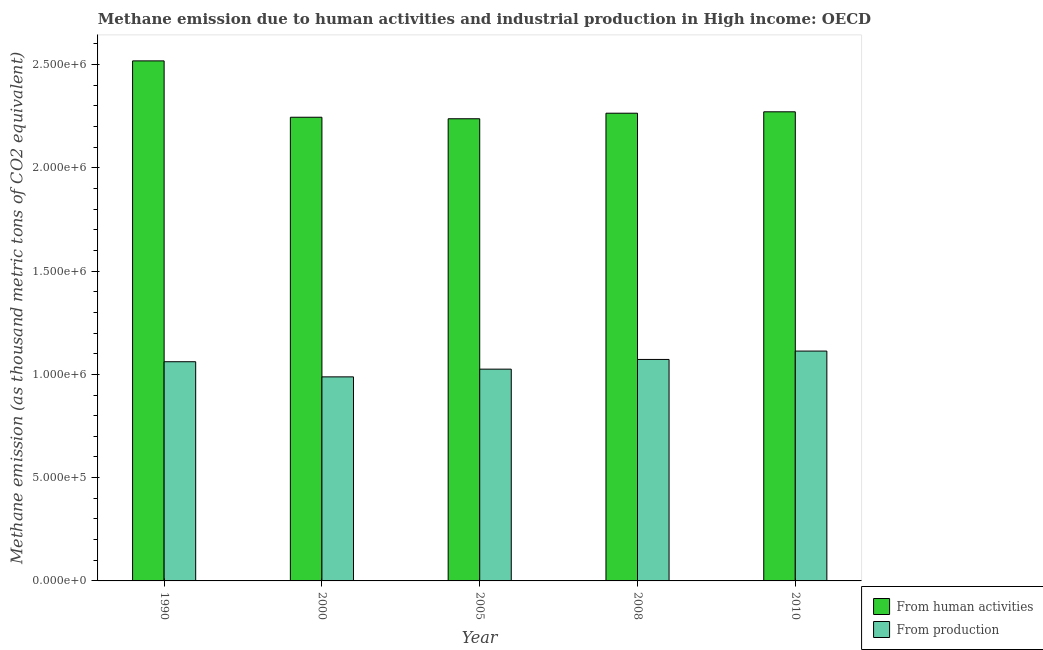How many different coloured bars are there?
Ensure brevity in your answer.  2. How many groups of bars are there?
Provide a short and direct response. 5. How many bars are there on the 3rd tick from the right?
Give a very brief answer. 2. In how many cases, is the number of bars for a given year not equal to the number of legend labels?
Keep it short and to the point. 0. What is the amount of emissions generated from industries in 1990?
Offer a terse response. 1.06e+06. Across all years, what is the maximum amount of emissions generated from industries?
Give a very brief answer. 1.11e+06. Across all years, what is the minimum amount of emissions generated from industries?
Provide a succinct answer. 9.88e+05. What is the total amount of emissions generated from industries in the graph?
Your response must be concise. 5.26e+06. What is the difference between the amount of emissions generated from industries in 1990 and that in 2000?
Provide a short and direct response. 7.33e+04. What is the difference between the amount of emissions generated from industries in 2005 and the amount of emissions from human activities in 2010?
Keep it short and to the point. -8.75e+04. What is the average amount of emissions from human activities per year?
Give a very brief answer. 2.31e+06. In the year 2000, what is the difference between the amount of emissions from human activities and amount of emissions generated from industries?
Provide a short and direct response. 0. In how many years, is the amount of emissions generated from industries greater than 1700000 thousand metric tons?
Provide a succinct answer. 0. What is the ratio of the amount of emissions from human activities in 2000 to that in 2010?
Make the answer very short. 0.99. Is the difference between the amount of emissions from human activities in 2000 and 2005 greater than the difference between the amount of emissions generated from industries in 2000 and 2005?
Provide a short and direct response. No. What is the difference between the highest and the second highest amount of emissions from human activities?
Your response must be concise. 2.47e+05. What is the difference between the highest and the lowest amount of emissions generated from industries?
Offer a very short reply. 1.25e+05. In how many years, is the amount of emissions generated from industries greater than the average amount of emissions generated from industries taken over all years?
Offer a terse response. 3. Is the sum of the amount of emissions from human activities in 1990 and 2005 greater than the maximum amount of emissions generated from industries across all years?
Provide a short and direct response. Yes. What does the 2nd bar from the left in 2005 represents?
Provide a succinct answer. From production. What does the 1st bar from the right in 1990 represents?
Make the answer very short. From production. Are all the bars in the graph horizontal?
Provide a succinct answer. No. Are the values on the major ticks of Y-axis written in scientific E-notation?
Provide a succinct answer. Yes. Does the graph contain any zero values?
Give a very brief answer. No. Where does the legend appear in the graph?
Make the answer very short. Bottom right. How are the legend labels stacked?
Give a very brief answer. Vertical. What is the title of the graph?
Provide a succinct answer. Methane emission due to human activities and industrial production in High income: OECD. What is the label or title of the Y-axis?
Provide a short and direct response. Methane emission (as thousand metric tons of CO2 equivalent). What is the Methane emission (as thousand metric tons of CO2 equivalent) in From human activities in 1990?
Ensure brevity in your answer.  2.52e+06. What is the Methane emission (as thousand metric tons of CO2 equivalent) of From production in 1990?
Provide a succinct answer. 1.06e+06. What is the Methane emission (as thousand metric tons of CO2 equivalent) in From human activities in 2000?
Give a very brief answer. 2.24e+06. What is the Methane emission (as thousand metric tons of CO2 equivalent) in From production in 2000?
Your answer should be compact. 9.88e+05. What is the Methane emission (as thousand metric tons of CO2 equivalent) in From human activities in 2005?
Your response must be concise. 2.24e+06. What is the Methane emission (as thousand metric tons of CO2 equivalent) of From production in 2005?
Your response must be concise. 1.03e+06. What is the Methane emission (as thousand metric tons of CO2 equivalent) in From human activities in 2008?
Your answer should be compact. 2.26e+06. What is the Methane emission (as thousand metric tons of CO2 equivalent) of From production in 2008?
Make the answer very short. 1.07e+06. What is the Methane emission (as thousand metric tons of CO2 equivalent) in From human activities in 2010?
Keep it short and to the point. 2.27e+06. What is the Methane emission (as thousand metric tons of CO2 equivalent) of From production in 2010?
Give a very brief answer. 1.11e+06. Across all years, what is the maximum Methane emission (as thousand metric tons of CO2 equivalent) of From human activities?
Offer a very short reply. 2.52e+06. Across all years, what is the maximum Methane emission (as thousand metric tons of CO2 equivalent) in From production?
Provide a succinct answer. 1.11e+06. Across all years, what is the minimum Methane emission (as thousand metric tons of CO2 equivalent) in From human activities?
Offer a very short reply. 2.24e+06. Across all years, what is the minimum Methane emission (as thousand metric tons of CO2 equivalent) in From production?
Provide a succinct answer. 9.88e+05. What is the total Methane emission (as thousand metric tons of CO2 equivalent) in From human activities in the graph?
Make the answer very short. 1.15e+07. What is the total Methane emission (as thousand metric tons of CO2 equivalent) in From production in the graph?
Make the answer very short. 5.26e+06. What is the difference between the Methane emission (as thousand metric tons of CO2 equivalent) in From human activities in 1990 and that in 2000?
Your response must be concise. 2.73e+05. What is the difference between the Methane emission (as thousand metric tons of CO2 equivalent) of From production in 1990 and that in 2000?
Your response must be concise. 7.33e+04. What is the difference between the Methane emission (as thousand metric tons of CO2 equivalent) of From human activities in 1990 and that in 2005?
Your response must be concise. 2.80e+05. What is the difference between the Methane emission (as thousand metric tons of CO2 equivalent) in From production in 1990 and that in 2005?
Your response must be concise. 3.59e+04. What is the difference between the Methane emission (as thousand metric tons of CO2 equivalent) of From human activities in 1990 and that in 2008?
Your response must be concise. 2.53e+05. What is the difference between the Methane emission (as thousand metric tons of CO2 equivalent) of From production in 1990 and that in 2008?
Offer a terse response. -1.11e+04. What is the difference between the Methane emission (as thousand metric tons of CO2 equivalent) in From human activities in 1990 and that in 2010?
Provide a short and direct response. 2.47e+05. What is the difference between the Methane emission (as thousand metric tons of CO2 equivalent) of From production in 1990 and that in 2010?
Provide a short and direct response. -5.16e+04. What is the difference between the Methane emission (as thousand metric tons of CO2 equivalent) in From human activities in 2000 and that in 2005?
Your answer should be compact. 7311.3. What is the difference between the Methane emission (as thousand metric tons of CO2 equivalent) of From production in 2000 and that in 2005?
Your answer should be compact. -3.74e+04. What is the difference between the Methane emission (as thousand metric tons of CO2 equivalent) in From human activities in 2000 and that in 2008?
Your answer should be very brief. -1.95e+04. What is the difference between the Methane emission (as thousand metric tons of CO2 equivalent) of From production in 2000 and that in 2008?
Provide a succinct answer. -8.44e+04. What is the difference between the Methane emission (as thousand metric tons of CO2 equivalent) in From human activities in 2000 and that in 2010?
Your answer should be very brief. -2.63e+04. What is the difference between the Methane emission (as thousand metric tons of CO2 equivalent) in From production in 2000 and that in 2010?
Your answer should be very brief. -1.25e+05. What is the difference between the Methane emission (as thousand metric tons of CO2 equivalent) in From human activities in 2005 and that in 2008?
Provide a short and direct response. -2.68e+04. What is the difference between the Methane emission (as thousand metric tons of CO2 equivalent) in From production in 2005 and that in 2008?
Offer a terse response. -4.70e+04. What is the difference between the Methane emission (as thousand metric tons of CO2 equivalent) in From human activities in 2005 and that in 2010?
Keep it short and to the point. -3.36e+04. What is the difference between the Methane emission (as thousand metric tons of CO2 equivalent) of From production in 2005 and that in 2010?
Offer a very short reply. -8.75e+04. What is the difference between the Methane emission (as thousand metric tons of CO2 equivalent) of From human activities in 2008 and that in 2010?
Provide a short and direct response. -6798. What is the difference between the Methane emission (as thousand metric tons of CO2 equivalent) of From production in 2008 and that in 2010?
Make the answer very short. -4.05e+04. What is the difference between the Methane emission (as thousand metric tons of CO2 equivalent) of From human activities in 1990 and the Methane emission (as thousand metric tons of CO2 equivalent) of From production in 2000?
Your answer should be very brief. 1.53e+06. What is the difference between the Methane emission (as thousand metric tons of CO2 equivalent) in From human activities in 1990 and the Methane emission (as thousand metric tons of CO2 equivalent) in From production in 2005?
Give a very brief answer. 1.49e+06. What is the difference between the Methane emission (as thousand metric tons of CO2 equivalent) in From human activities in 1990 and the Methane emission (as thousand metric tons of CO2 equivalent) in From production in 2008?
Keep it short and to the point. 1.45e+06. What is the difference between the Methane emission (as thousand metric tons of CO2 equivalent) in From human activities in 1990 and the Methane emission (as thousand metric tons of CO2 equivalent) in From production in 2010?
Offer a terse response. 1.40e+06. What is the difference between the Methane emission (as thousand metric tons of CO2 equivalent) in From human activities in 2000 and the Methane emission (as thousand metric tons of CO2 equivalent) in From production in 2005?
Offer a very short reply. 1.22e+06. What is the difference between the Methane emission (as thousand metric tons of CO2 equivalent) in From human activities in 2000 and the Methane emission (as thousand metric tons of CO2 equivalent) in From production in 2008?
Offer a terse response. 1.17e+06. What is the difference between the Methane emission (as thousand metric tons of CO2 equivalent) of From human activities in 2000 and the Methane emission (as thousand metric tons of CO2 equivalent) of From production in 2010?
Offer a terse response. 1.13e+06. What is the difference between the Methane emission (as thousand metric tons of CO2 equivalent) in From human activities in 2005 and the Methane emission (as thousand metric tons of CO2 equivalent) in From production in 2008?
Your answer should be very brief. 1.17e+06. What is the difference between the Methane emission (as thousand metric tons of CO2 equivalent) of From human activities in 2005 and the Methane emission (as thousand metric tons of CO2 equivalent) of From production in 2010?
Give a very brief answer. 1.12e+06. What is the difference between the Methane emission (as thousand metric tons of CO2 equivalent) in From human activities in 2008 and the Methane emission (as thousand metric tons of CO2 equivalent) in From production in 2010?
Your answer should be compact. 1.15e+06. What is the average Methane emission (as thousand metric tons of CO2 equivalent) of From human activities per year?
Your response must be concise. 2.31e+06. What is the average Methane emission (as thousand metric tons of CO2 equivalent) of From production per year?
Provide a short and direct response. 1.05e+06. In the year 1990, what is the difference between the Methane emission (as thousand metric tons of CO2 equivalent) of From human activities and Methane emission (as thousand metric tons of CO2 equivalent) of From production?
Make the answer very short. 1.46e+06. In the year 2000, what is the difference between the Methane emission (as thousand metric tons of CO2 equivalent) of From human activities and Methane emission (as thousand metric tons of CO2 equivalent) of From production?
Your answer should be compact. 1.26e+06. In the year 2005, what is the difference between the Methane emission (as thousand metric tons of CO2 equivalent) in From human activities and Methane emission (as thousand metric tons of CO2 equivalent) in From production?
Offer a very short reply. 1.21e+06. In the year 2008, what is the difference between the Methane emission (as thousand metric tons of CO2 equivalent) of From human activities and Methane emission (as thousand metric tons of CO2 equivalent) of From production?
Offer a very short reply. 1.19e+06. In the year 2010, what is the difference between the Methane emission (as thousand metric tons of CO2 equivalent) in From human activities and Methane emission (as thousand metric tons of CO2 equivalent) in From production?
Ensure brevity in your answer.  1.16e+06. What is the ratio of the Methane emission (as thousand metric tons of CO2 equivalent) of From human activities in 1990 to that in 2000?
Offer a terse response. 1.12. What is the ratio of the Methane emission (as thousand metric tons of CO2 equivalent) of From production in 1990 to that in 2000?
Your response must be concise. 1.07. What is the ratio of the Methane emission (as thousand metric tons of CO2 equivalent) in From human activities in 1990 to that in 2005?
Offer a very short reply. 1.13. What is the ratio of the Methane emission (as thousand metric tons of CO2 equivalent) in From production in 1990 to that in 2005?
Your response must be concise. 1.03. What is the ratio of the Methane emission (as thousand metric tons of CO2 equivalent) in From human activities in 1990 to that in 2008?
Offer a very short reply. 1.11. What is the ratio of the Methane emission (as thousand metric tons of CO2 equivalent) in From production in 1990 to that in 2008?
Offer a very short reply. 0.99. What is the ratio of the Methane emission (as thousand metric tons of CO2 equivalent) in From human activities in 1990 to that in 2010?
Offer a terse response. 1.11. What is the ratio of the Methane emission (as thousand metric tons of CO2 equivalent) of From production in 1990 to that in 2010?
Give a very brief answer. 0.95. What is the ratio of the Methane emission (as thousand metric tons of CO2 equivalent) of From production in 2000 to that in 2005?
Provide a short and direct response. 0.96. What is the ratio of the Methane emission (as thousand metric tons of CO2 equivalent) in From production in 2000 to that in 2008?
Keep it short and to the point. 0.92. What is the ratio of the Methane emission (as thousand metric tons of CO2 equivalent) of From human activities in 2000 to that in 2010?
Keep it short and to the point. 0.99. What is the ratio of the Methane emission (as thousand metric tons of CO2 equivalent) in From production in 2000 to that in 2010?
Give a very brief answer. 0.89. What is the ratio of the Methane emission (as thousand metric tons of CO2 equivalent) in From human activities in 2005 to that in 2008?
Offer a very short reply. 0.99. What is the ratio of the Methane emission (as thousand metric tons of CO2 equivalent) in From production in 2005 to that in 2008?
Keep it short and to the point. 0.96. What is the ratio of the Methane emission (as thousand metric tons of CO2 equivalent) in From human activities in 2005 to that in 2010?
Your answer should be compact. 0.99. What is the ratio of the Methane emission (as thousand metric tons of CO2 equivalent) of From production in 2005 to that in 2010?
Ensure brevity in your answer.  0.92. What is the ratio of the Methane emission (as thousand metric tons of CO2 equivalent) of From human activities in 2008 to that in 2010?
Ensure brevity in your answer.  1. What is the ratio of the Methane emission (as thousand metric tons of CO2 equivalent) of From production in 2008 to that in 2010?
Offer a very short reply. 0.96. What is the difference between the highest and the second highest Methane emission (as thousand metric tons of CO2 equivalent) of From human activities?
Offer a terse response. 2.47e+05. What is the difference between the highest and the second highest Methane emission (as thousand metric tons of CO2 equivalent) in From production?
Provide a short and direct response. 4.05e+04. What is the difference between the highest and the lowest Methane emission (as thousand metric tons of CO2 equivalent) of From human activities?
Give a very brief answer. 2.80e+05. What is the difference between the highest and the lowest Methane emission (as thousand metric tons of CO2 equivalent) in From production?
Your response must be concise. 1.25e+05. 